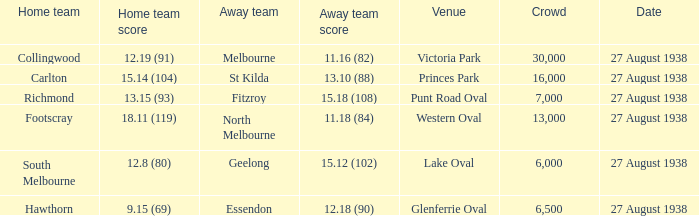What is the average crowd attendance for Collingwood? 30000.0. 